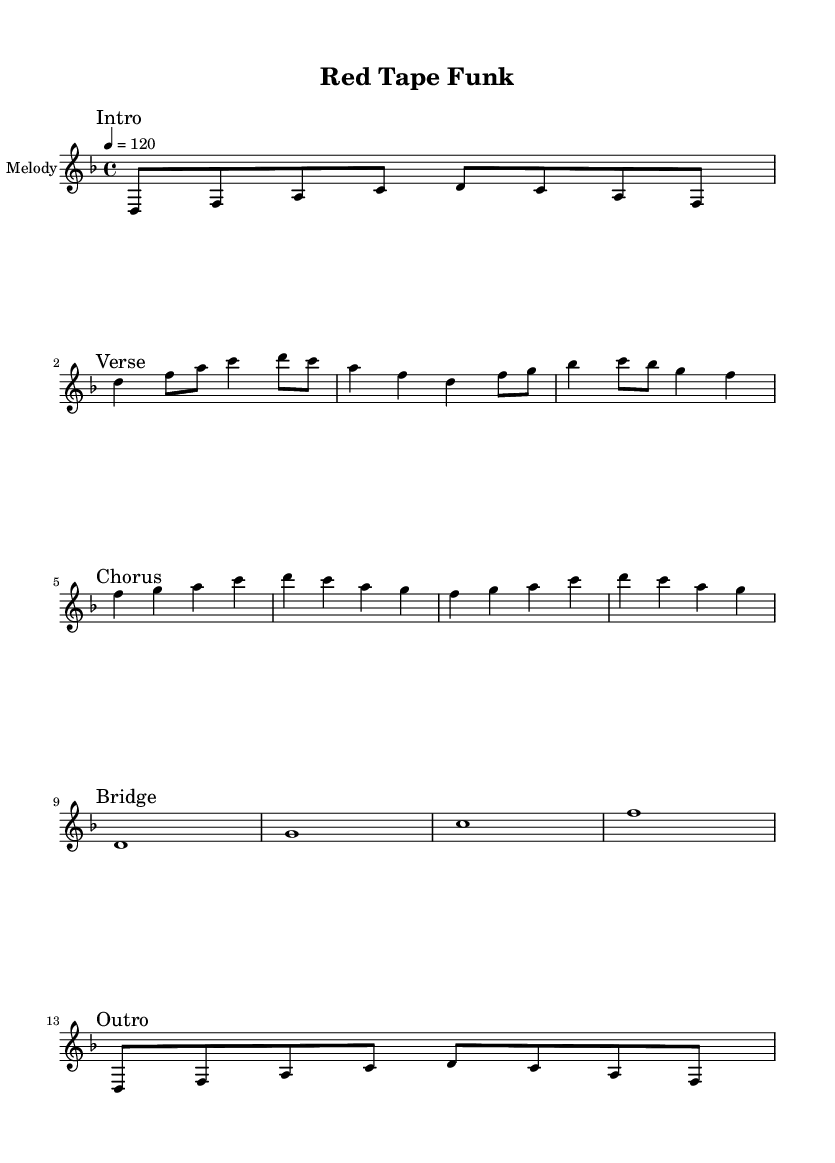What is the key signature of this music? The key signature is indicated at the beginning of the staff with one flat next to the clef. This indicates that the music is in D minor, which has one flat.
Answer: D minor What is the time signature of this piece? The time signature is shown at the beginning of the music, where it reads "4/4." This means there are four beats in each measure and the quarter note gets one beat.
Answer: 4/4 What is the tempo marking of this piece? The tempo marking is found at the beginning of the music, specified as "4 = 120." This indicates the tempo of the piece is 120 beats per minute, with each beat representing a quarter note.
Answer: 120 How many measures are there in the chorus section? To find the number of measures in the chorus, count the measures that are explicitly noted. The chorus has two measures, each consisting of four beats, which is a standard structure for many musical sections.
Answer: 2 What is the rhythmic pattern of the main riff? The main riff consists of eight eighth notes and is structured as "d8 f a c d c a f," indicating a funky, syncopated rhythm typical of funk music. This pattern sets the feel for the entire piece.
Answer: d f a c d c a f What is the primary theme expressed in the lyrics? The lyrics explicitly discuss the tension between mobile clinics and bureaucratic standardization, indicating a critical view of alternative healthcare methods, which is a common and thematic content in funk music that often addresses social issues.
Answer: Bureaucracy What style of music does this sheet music represent? The overall characteristics of the rhythm, syncopation, and lyrical themes indicate that this piece is classified as funk music, which typically focuses on a strong rhythmic groove and often engages with social commentary.
Answer: Funk 